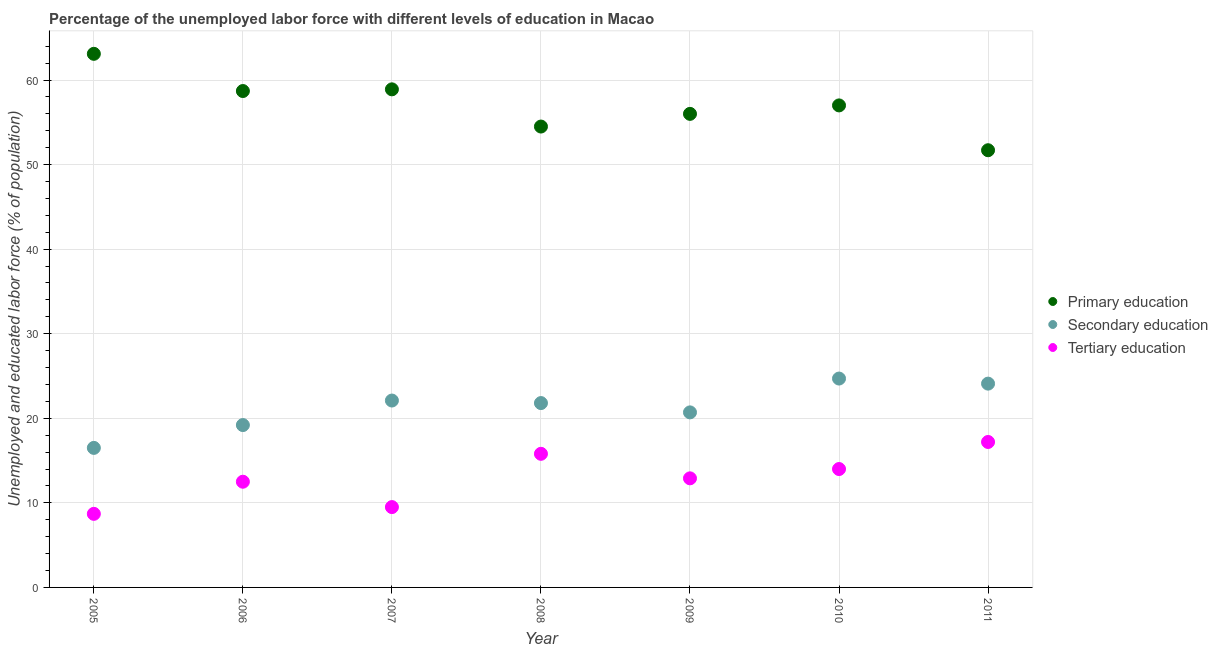Is the number of dotlines equal to the number of legend labels?
Your answer should be compact. Yes. What is the percentage of labor force who received secondary education in 2009?
Your answer should be compact. 20.7. Across all years, what is the maximum percentage of labor force who received secondary education?
Your response must be concise. 24.7. Across all years, what is the minimum percentage of labor force who received primary education?
Provide a short and direct response. 51.7. In which year was the percentage of labor force who received primary education maximum?
Provide a succinct answer. 2005. In which year was the percentage of labor force who received tertiary education minimum?
Make the answer very short. 2005. What is the total percentage of labor force who received secondary education in the graph?
Your answer should be compact. 149.1. What is the difference between the percentage of labor force who received secondary education in 2006 and the percentage of labor force who received tertiary education in 2008?
Your answer should be compact. 3.4. What is the average percentage of labor force who received secondary education per year?
Provide a short and direct response. 21.3. In the year 2007, what is the difference between the percentage of labor force who received secondary education and percentage of labor force who received tertiary education?
Your answer should be very brief. 12.6. What is the ratio of the percentage of labor force who received primary education in 2008 to that in 2009?
Offer a terse response. 0.97. Is the percentage of labor force who received primary education in 2007 less than that in 2010?
Keep it short and to the point. No. What is the difference between the highest and the second highest percentage of labor force who received primary education?
Give a very brief answer. 4.2. What is the difference between the highest and the lowest percentage of labor force who received secondary education?
Keep it short and to the point. 8.2. In how many years, is the percentage of labor force who received secondary education greater than the average percentage of labor force who received secondary education taken over all years?
Your answer should be compact. 4. Is the sum of the percentage of labor force who received tertiary education in 2005 and 2011 greater than the maximum percentage of labor force who received primary education across all years?
Offer a terse response. No. How many years are there in the graph?
Give a very brief answer. 7. How many legend labels are there?
Provide a succinct answer. 3. How are the legend labels stacked?
Offer a terse response. Vertical. What is the title of the graph?
Provide a short and direct response. Percentage of the unemployed labor force with different levels of education in Macao. Does "Taxes on goods and services" appear as one of the legend labels in the graph?
Offer a terse response. No. What is the label or title of the Y-axis?
Offer a very short reply. Unemployed and educated labor force (% of population). What is the Unemployed and educated labor force (% of population) in Primary education in 2005?
Offer a very short reply. 63.1. What is the Unemployed and educated labor force (% of population) in Secondary education in 2005?
Your response must be concise. 16.5. What is the Unemployed and educated labor force (% of population) in Tertiary education in 2005?
Provide a short and direct response. 8.7. What is the Unemployed and educated labor force (% of population) in Primary education in 2006?
Your answer should be compact. 58.7. What is the Unemployed and educated labor force (% of population) in Secondary education in 2006?
Offer a terse response. 19.2. What is the Unemployed and educated labor force (% of population) of Primary education in 2007?
Offer a very short reply. 58.9. What is the Unemployed and educated labor force (% of population) in Secondary education in 2007?
Provide a succinct answer. 22.1. What is the Unemployed and educated labor force (% of population) of Primary education in 2008?
Your answer should be very brief. 54.5. What is the Unemployed and educated labor force (% of population) of Secondary education in 2008?
Keep it short and to the point. 21.8. What is the Unemployed and educated labor force (% of population) in Tertiary education in 2008?
Keep it short and to the point. 15.8. What is the Unemployed and educated labor force (% of population) of Secondary education in 2009?
Offer a terse response. 20.7. What is the Unemployed and educated labor force (% of population) of Tertiary education in 2009?
Your response must be concise. 12.9. What is the Unemployed and educated labor force (% of population) in Secondary education in 2010?
Ensure brevity in your answer.  24.7. What is the Unemployed and educated labor force (% of population) in Tertiary education in 2010?
Ensure brevity in your answer.  14. What is the Unemployed and educated labor force (% of population) of Primary education in 2011?
Your answer should be compact. 51.7. What is the Unemployed and educated labor force (% of population) of Secondary education in 2011?
Keep it short and to the point. 24.1. What is the Unemployed and educated labor force (% of population) of Tertiary education in 2011?
Make the answer very short. 17.2. Across all years, what is the maximum Unemployed and educated labor force (% of population) of Primary education?
Offer a terse response. 63.1. Across all years, what is the maximum Unemployed and educated labor force (% of population) of Secondary education?
Provide a short and direct response. 24.7. Across all years, what is the maximum Unemployed and educated labor force (% of population) in Tertiary education?
Make the answer very short. 17.2. Across all years, what is the minimum Unemployed and educated labor force (% of population) in Primary education?
Your answer should be compact. 51.7. Across all years, what is the minimum Unemployed and educated labor force (% of population) in Tertiary education?
Provide a short and direct response. 8.7. What is the total Unemployed and educated labor force (% of population) of Primary education in the graph?
Offer a terse response. 399.9. What is the total Unemployed and educated labor force (% of population) of Secondary education in the graph?
Your answer should be compact. 149.1. What is the total Unemployed and educated labor force (% of population) of Tertiary education in the graph?
Your response must be concise. 90.6. What is the difference between the Unemployed and educated labor force (% of population) of Secondary education in 2005 and that in 2006?
Make the answer very short. -2.7. What is the difference between the Unemployed and educated labor force (% of population) of Secondary education in 2005 and that in 2007?
Make the answer very short. -5.6. What is the difference between the Unemployed and educated labor force (% of population) in Tertiary education in 2005 and that in 2007?
Make the answer very short. -0.8. What is the difference between the Unemployed and educated labor force (% of population) of Secondary education in 2005 and that in 2008?
Offer a terse response. -5.3. What is the difference between the Unemployed and educated labor force (% of population) in Primary education in 2005 and that in 2009?
Ensure brevity in your answer.  7.1. What is the difference between the Unemployed and educated labor force (% of population) in Secondary education in 2005 and that in 2009?
Keep it short and to the point. -4.2. What is the difference between the Unemployed and educated labor force (% of population) in Tertiary education in 2005 and that in 2010?
Offer a very short reply. -5.3. What is the difference between the Unemployed and educated labor force (% of population) in Primary education in 2005 and that in 2011?
Ensure brevity in your answer.  11.4. What is the difference between the Unemployed and educated labor force (% of population) of Tertiary education in 2005 and that in 2011?
Give a very brief answer. -8.5. What is the difference between the Unemployed and educated labor force (% of population) of Primary education in 2006 and that in 2007?
Your answer should be very brief. -0.2. What is the difference between the Unemployed and educated labor force (% of population) of Secondary education in 2006 and that in 2007?
Offer a very short reply. -2.9. What is the difference between the Unemployed and educated labor force (% of population) in Primary education in 2006 and that in 2008?
Provide a short and direct response. 4.2. What is the difference between the Unemployed and educated labor force (% of population) of Secondary education in 2006 and that in 2008?
Make the answer very short. -2.6. What is the difference between the Unemployed and educated labor force (% of population) of Tertiary education in 2006 and that in 2008?
Provide a succinct answer. -3.3. What is the difference between the Unemployed and educated labor force (% of population) in Secondary education in 2006 and that in 2009?
Offer a terse response. -1.5. What is the difference between the Unemployed and educated labor force (% of population) of Tertiary education in 2006 and that in 2009?
Give a very brief answer. -0.4. What is the difference between the Unemployed and educated labor force (% of population) in Primary education in 2006 and that in 2011?
Your response must be concise. 7. What is the difference between the Unemployed and educated labor force (% of population) of Secondary education in 2006 and that in 2011?
Give a very brief answer. -4.9. What is the difference between the Unemployed and educated labor force (% of population) in Tertiary education in 2006 and that in 2011?
Keep it short and to the point. -4.7. What is the difference between the Unemployed and educated labor force (% of population) of Secondary education in 2007 and that in 2008?
Your response must be concise. 0.3. What is the difference between the Unemployed and educated labor force (% of population) in Tertiary education in 2007 and that in 2009?
Keep it short and to the point. -3.4. What is the difference between the Unemployed and educated labor force (% of population) in Tertiary education in 2007 and that in 2010?
Ensure brevity in your answer.  -4.5. What is the difference between the Unemployed and educated labor force (% of population) of Primary education in 2007 and that in 2011?
Keep it short and to the point. 7.2. What is the difference between the Unemployed and educated labor force (% of population) of Tertiary education in 2007 and that in 2011?
Make the answer very short. -7.7. What is the difference between the Unemployed and educated labor force (% of population) of Primary education in 2008 and that in 2009?
Provide a succinct answer. -1.5. What is the difference between the Unemployed and educated labor force (% of population) in Tertiary education in 2008 and that in 2009?
Give a very brief answer. 2.9. What is the difference between the Unemployed and educated labor force (% of population) in Primary education in 2008 and that in 2010?
Your answer should be very brief. -2.5. What is the difference between the Unemployed and educated labor force (% of population) of Secondary education in 2008 and that in 2010?
Provide a short and direct response. -2.9. What is the difference between the Unemployed and educated labor force (% of population) of Tertiary education in 2008 and that in 2010?
Make the answer very short. 1.8. What is the difference between the Unemployed and educated labor force (% of population) of Secondary education in 2009 and that in 2010?
Your response must be concise. -4. What is the difference between the Unemployed and educated labor force (% of population) of Tertiary education in 2009 and that in 2010?
Offer a very short reply. -1.1. What is the difference between the Unemployed and educated labor force (% of population) of Secondary education in 2009 and that in 2011?
Ensure brevity in your answer.  -3.4. What is the difference between the Unemployed and educated labor force (% of population) of Primary education in 2010 and that in 2011?
Offer a very short reply. 5.3. What is the difference between the Unemployed and educated labor force (% of population) in Tertiary education in 2010 and that in 2011?
Offer a terse response. -3.2. What is the difference between the Unemployed and educated labor force (% of population) of Primary education in 2005 and the Unemployed and educated labor force (% of population) of Secondary education in 2006?
Your response must be concise. 43.9. What is the difference between the Unemployed and educated labor force (% of population) in Primary education in 2005 and the Unemployed and educated labor force (% of population) in Tertiary education in 2006?
Offer a terse response. 50.6. What is the difference between the Unemployed and educated labor force (% of population) in Primary education in 2005 and the Unemployed and educated labor force (% of population) in Tertiary education in 2007?
Offer a terse response. 53.6. What is the difference between the Unemployed and educated labor force (% of population) in Primary education in 2005 and the Unemployed and educated labor force (% of population) in Secondary education in 2008?
Ensure brevity in your answer.  41.3. What is the difference between the Unemployed and educated labor force (% of population) in Primary education in 2005 and the Unemployed and educated labor force (% of population) in Tertiary education in 2008?
Your response must be concise. 47.3. What is the difference between the Unemployed and educated labor force (% of population) of Primary education in 2005 and the Unemployed and educated labor force (% of population) of Secondary education in 2009?
Offer a terse response. 42.4. What is the difference between the Unemployed and educated labor force (% of population) in Primary education in 2005 and the Unemployed and educated labor force (% of population) in Tertiary education in 2009?
Your answer should be very brief. 50.2. What is the difference between the Unemployed and educated labor force (% of population) in Primary education in 2005 and the Unemployed and educated labor force (% of population) in Secondary education in 2010?
Your answer should be very brief. 38.4. What is the difference between the Unemployed and educated labor force (% of population) in Primary education in 2005 and the Unemployed and educated labor force (% of population) in Tertiary education in 2010?
Keep it short and to the point. 49.1. What is the difference between the Unemployed and educated labor force (% of population) in Primary education in 2005 and the Unemployed and educated labor force (% of population) in Tertiary education in 2011?
Make the answer very short. 45.9. What is the difference between the Unemployed and educated labor force (% of population) of Secondary education in 2005 and the Unemployed and educated labor force (% of population) of Tertiary education in 2011?
Make the answer very short. -0.7. What is the difference between the Unemployed and educated labor force (% of population) of Primary education in 2006 and the Unemployed and educated labor force (% of population) of Secondary education in 2007?
Ensure brevity in your answer.  36.6. What is the difference between the Unemployed and educated labor force (% of population) of Primary education in 2006 and the Unemployed and educated labor force (% of population) of Tertiary education in 2007?
Ensure brevity in your answer.  49.2. What is the difference between the Unemployed and educated labor force (% of population) of Secondary education in 2006 and the Unemployed and educated labor force (% of population) of Tertiary education in 2007?
Your response must be concise. 9.7. What is the difference between the Unemployed and educated labor force (% of population) of Primary education in 2006 and the Unemployed and educated labor force (% of population) of Secondary education in 2008?
Your answer should be compact. 36.9. What is the difference between the Unemployed and educated labor force (% of population) in Primary education in 2006 and the Unemployed and educated labor force (% of population) in Tertiary education in 2008?
Your answer should be compact. 42.9. What is the difference between the Unemployed and educated labor force (% of population) of Primary education in 2006 and the Unemployed and educated labor force (% of population) of Secondary education in 2009?
Offer a terse response. 38. What is the difference between the Unemployed and educated labor force (% of population) in Primary education in 2006 and the Unemployed and educated labor force (% of population) in Tertiary education in 2009?
Your response must be concise. 45.8. What is the difference between the Unemployed and educated labor force (% of population) of Secondary education in 2006 and the Unemployed and educated labor force (% of population) of Tertiary education in 2009?
Provide a short and direct response. 6.3. What is the difference between the Unemployed and educated labor force (% of population) of Primary education in 2006 and the Unemployed and educated labor force (% of population) of Secondary education in 2010?
Give a very brief answer. 34. What is the difference between the Unemployed and educated labor force (% of population) of Primary education in 2006 and the Unemployed and educated labor force (% of population) of Tertiary education in 2010?
Provide a succinct answer. 44.7. What is the difference between the Unemployed and educated labor force (% of population) in Secondary education in 2006 and the Unemployed and educated labor force (% of population) in Tertiary education in 2010?
Your answer should be compact. 5.2. What is the difference between the Unemployed and educated labor force (% of population) of Primary education in 2006 and the Unemployed and educated labor force (% of population) of Secondary education in 2011?
Your answer should be compact. 34.6. What is the difference between the Unemployed and educated labor force (% of population) of Primary education in 2006 and the Unemployed and educated labor force (% of population) of Tertiary education in 2011?
Provide a succinct answer. 41.5. What is the difference between the Unemployed and educated labor force (% of population) of Primary education in 2007 and the Unemployed and educated labor force (% of population) of Secondary education in 2008?
Keep it short and to the point. 37.1. What is the difference between the Unemployed and educated labor force (% of population) in Primary education in 2007 and the Unemployed and educated labor force (% of population) in Tertiary education in 2008?
Offer a very short reply. 43.1. What is the difference between the Unemployed and educated labor force (% of population) of Secondary education in 2007 and the Unemployed and educated labor force (% of population) of Tertiary education in 2008?
Offer a very short reply. 6.3. What is the difference between the Unemployed and educated labor force (% of population) of Primary education in 2007 and the Unemployed and educated labor force (% of population) of Secondary education in 2009?
Keep it short and to the point. 38.2. What is the difference between the Unemployed and educated labor force (% of population) in Primary education in 2007 and the Unemployed and educated labor force (% of population) in Secondary education in 2010?
Your answer should be compact. 34.2. What is the difference between the Unemployed and educated labor force (% of population) in Primary education in 2007 and the Unemployed and educated labor force (% of population) in Tertiary education in 2010?
Your response must be concise. 44.9. What is the difference between the Unemployed and educated labor force (% of population) of Primary education in 2007 and the Unemployed and educated labor force (% of population) of Secondary education in 2011?
Your answer should be very brief. 34.8. What is the difference between the Unemployed and educated labor force (% of population) in Primary education in 2007 and the Unemployed and educated labor force (% of population) in Tertiary education in 2011?
Your answer should be very brief. 41.7. What is the difference between the Unemployed and educated labor force (% of population) in Secondary education in 2007 and the Unemployed and educated labor force (% of population) in Tertiary education in 2011?
Give a very brief answer. 4.9. What is the difference between the Unemployed and educated labor force (% of population) of Primary education in 2008 and the Unemployed and educated labor force (% of population) of Secondary education in 2009?
Your answer should be compact. 33.8. What is the difference between the Unemployed and educated labor force (% of population) in Primary education in 2008 and the Unemployed and educated labor force (% of population) in Tertiary education in 2009?
Your answer should be compact. 41.6. What is the difference between the Unemployed and educated labor force (% of population) in Primary education in 2008 and the Unemployed and educated labor force (% of population) in Secondary education in 2010?
Provide a succinct answer. 29.8. What is the difference between the Unemployed and educated labor force (% of population) in Primary education in 2008 and the Unemployed and educated labor force (% of population) in Tertiary education in 2010?
Your answer should be compact. 40.5. What is the difference between the Unemployed and educated labor force (% of population) of Secondary education in 2008 and the Unemployed and educated labor force (% of population) of Tertiary education in 2010?
Provide a short and direct response. 7.8. What is the difference between the Unemployed and educated labor force (% of population) of Primary education in 2008 and the Unemployed and educated labor force (% of population) of Secondary education in 2011?
Your response must be concise. 30.4. What is the difference between the Unemployed and educated labor force (% of population) in Primary education in 2008 and the Unemployed and educated labor force (% of population) in Tertiary education in 2011?
Ensure brevity in your answer.  37.3. What is the difference between the Unemployed and educated labor force (% of population) in Primary education in 2009 and the Unemployed and educated labor force (% of population) in Secondary education in 2010?
Give a very brief answer. 31.3. What is the difference between the Unemployed and educated labor force (% of population) of Primary education in 2009 and the Unemployed and educated labor force (% of population) of Secondary education in 2011?
Ensure brevity in your answer.  31.9. What is the difference between the Unemployed and educated labor force (% of population) of Primary education in 2009 and the Unemployed and educated labor force (% of population) of Tertiary education in 2011?
Provide a succinct answer. 38.8. What is the difference between the Unemployed and educated labor force (% of population) in Secondary education in 2009 and the Unemployed and educated labor force (% of population) in Tertiary education in 2011?
Your response must be concise. 3.5. What is the difference between the Unemployed and educated labor force (% of population) of Primary education in 2010 and the Unemployed and educated labor force (% of population) of Secondary education in 2011?
Offer a terse response. 32.9. What is the difference between the Unemployed and educated labor force (% of population) in Primary education in 2010 and the Unemployed and educated labor force (% of population) in Tertiary education in 2011?
Keep it short and to the point. 39.8. What is the average Unemployed and educated labor force (% of population) in Primary education per year?
Offer a very short reply. 57.13. What is the average Unemployed and educated labor force (% of population) of Secondary education per year?
Keep it short and to the point. 21.3. What is the average Unemployed and educated labor force (% of population) in Tertiary education per year?
Your answer should be compact. 12.94. In the year 2005, what is the difference between the Unemployed and educated labor force (% of population) in Primary education and Unemployed and educated labor force (% of population) in Secondary education?
Offer a terse response. 46.6. In the year 2005, what is the difference between the Unemployed and educated labor force (% of population) in Primary education and Unemployed and educated labor force (% of population) in Tertiary education?
Your response must be concise. 54.4. In the year 2005, what is the difference between the Unemployed and educated labor force (% of population) in Secondary education and Unemployed and educated labor force (% of population) in Tertiary education?
Ensure brevity in your answer.  7.8. In the year 2006, what is the difference between the Unemployed and educated labor force (% of population) of Primary education and Unemployed and educated labor force (% of population) of Secondary education?
Give a very brief answer. 39.5. In the year 2006, what is the difference between the Unemployed and educated labor force (% of population) of Primary education and Unemployed and educated labor force (% of population) of Tertiary education?
Make the answer very short. 46.2. In the year 2006, what is the difference between the Unemployed and educated labor force (% of population) in Secondary education and Unemployed and educated labor force (% of population) in Tertiary education?
Ensure brevity in your answer.  6.7. In the year 2007, what is the difference between the Unemployed and educated labor force (% of population) in Primary education and Unemployed and educated labor force (% of population) in Secondary education?
Provide a succinct answer. 36.8. In the year 2007, what is the difference between the Unemployed and educated labor force (% of population) in Primary education and Unemployed and educated labor force (% of population) in Tertiary education?
Your response must be concise. 49.4. In the year 2008, what is the difference between the Unemployed and educated labor force (% of population) in Primary education and Unemployed and educated labor force (% of population) in Secondary education?
Your answer should be very brief. 32.7. In the year 2008, what is the difference between the Unemployed and educated labor force (% of population) of Primary education and Unemployed and educated labor force (% of population) of Tertiary education?
Offer a terse response. 38.7. In the year 2009, what is the difference between the Unemployed and educated labor force (% of population) in Primary education and Unemployed and educated labor force (% of population) in Secondary education?
Keep it short and to the point. 35.3. In the year 2009, what is the difference between the Unemployed and educated labor force (% of population) of Primary education and Unemployed and educated labor force (% of population) of Tertiary education?
Provide a short and direct response. 43.1. In the year 2010, what is the difference between the Unemployed and educated labor force (% of population) of Primary education and Unemployed and educated labor force (% of population) of Secondary education?
Provide a short and direct response. 32.3. In the year 2010, what is the difference between the Unemployed and educated labor force (% of population) of Secondary education and Unemployed and educated labor force (% of population) of Tertiary education?
Provide a short and direct response. 10.7. In the year 2011, what is the difference between the Unemployed and educated labor force (% of population) in Primary education and Unemployed and educated labor force (% of population) in Secondary education?
Offer a terse response. 27.6. In the year 2011, what is the difference between the Unemployed and educated labor force (% of population) of Primary education and Unemployed and educated labor force (% of population) of Tertiary education?
Your response must be concise. 34.5. What is the ratio of the Unemployed and educated labor force (% of population) of Primary education in 2005 to that in 2006?
Your answer should be very brief. 1.07. What is the ratio of the Unemployed and educated labor force (% of population) in Secondary education in 2005 to that in 2006?
Offer a terse response. 0.86. What is the ratio of the Unemployed and educated labor force (% of population) of Tertiary education in 2005 to that in 2006?
Provide a succinct answer. 0.7. What is the ratio of the Unemployed and educated labor force (% of population) of Primary education in 2005 to that in 2007?
Provide a short and direct response. 1.07. What is the ratio of the Unemployed and educated labor force (% of population) in Secondary education in 2005 to that in 2007?
Ensure brevity in your answer.  0.75. What is the ratio of the Unemployed and educated labor force (% of population) in Tertiary education in 2005 to that in 2007?
Give a very brief answer. 0.92. What is the ratio of the Unemployed and educated labor force (% of population) in Primary education in 2005 to that in 2008?
Keep it short and to the point. 1.16. What is the ratio of the Unemployed and educated labor force (% of population) of Secondary education in 2005 to that in 2008?
Give a very brief answer. 0.76. What is the ratio of the Unemployed and educated labor force (% of population) in Tertiary education in 2005 to that in 2008?
Offer a terse response. 0.55. What is the ratio of the Unemployed and educated labor force (% of population) of Primary education in 2005 to that in 2009?
Make the answer very short. 1.13. What is the ratio of the Unemployed and educated labor force (% of population) in Secondary education in 2005 to that in 2009?
Keep it short and to the point. 0.8. What is the ratio of the Unemployed and educated labor force (% of population) in Tertiary education in 2005 to that in 2009?
Provide a succinct answer. 0.67. What is the ratio of the Unemployed and educated labor force (% of population) of Primary education in 2005 to that in 2010?
Keep it short and to the point. 1.11. What is the ratio of the Unemployed and educated labor force (% of population) of Secondary education in 2005 to that in 2010?
Offer a terse response. 0.67. What is the ratio of the Unemployed and educated labor force (% of population) of Tertiary education in 2005 to that in 2010?
Your response must be concise. 0.62. What is the ratio of the Unemployed and educated labor force (% of population) of Primary education in 2005 to that in 2011?
Offer a very short reply. 1.22. What is the ratio of the Unemployed and educated labor force (% of population) of Secondary education in 2005 to that in 2011?
Ensure brevity in your answer.  0.68. What is the ratio of the Unemployed and educated labor force (% of population) of Tertiary education in 2005 to that in 2011?
Offer a terse response. 0.51. What is the ratio of the Unemployed and educated labor force (% of population) of Secondary education in 2006 to that in 2007?
Ensure brevity in your answer.  0.87. What is the ratio of the Unemployed and educated labor force (% of population) in Tertiary education in 2006 to that in 2007?
Ensure brevity in your answer.  1.32. What is the ratio of the Unemployed and educated labor force (% of population) in Primary education in 2006 to that in 2008?
Offer a terse response. 1.08. What is the ratio of the Unemployed and educated labor force (% of population) in Secondary education in 2006 to that in 2008?
Provide a succinct answer. 0.88. What is the ratio of the Unemployed and educated labor force (% of population) in Tertiary education in 2006 to that in 2008?
Your answer should be compact. 0.79. What is the ratio of the Unemployed and educated labor force (% of population) of Primary education in 2006 to that in 2009?
Keep it short and to the point. 1.05. What is the ratio of the Unemployed and educated labor force (% of population) in Secondary education in 2006 to that in 2009?
Make the answer very short. 0.93. What is the ratio of the Unemployed and educated labor force (% of population) of Primary education in 2006 to that in 2010?
Your answer should be very brief. 1.03. What is the ratio of the Unemployed and educated labor force (% of population) of Secondary education in 2006 to that in 2010?
Offer a very short reply. 0.78. What is the ratio of the Unemployed and educated labor force (% of population) in Tertiary education in 2006 to that in 2010?
Ensure brevity in your answer.  0.89. What is the ratio of the Unemployed and educated labor force (% of population) of Primary education in 2006 to that in 2011?
Offer a terse response. 1.14. What is the ratio of the Unemployed and educated labor force (% of population) of Secondary education in 2006 to that in 2011?
Provide a short and direct response. 0.8. What is the ratio of the Unemployed and educated labor force (% of population) in Tertiary education in 2006 to that in 2011?
Ensure brevity in your answer.  0.73. What is the ratio of the Unemployed and educated labor force (% of population) in Primary education in 2007 to that in 2008?
Your answer should be very brief. 1.08. What is the ratio of the Unemployed and educated labor force (% of population) in Secondary education in 2007 to that in 2008?
Provide a succinct answer. 1.01. What is the ratio of the Unemployed and educated labor force (% of population) in Tertiary education in 2007 to that in 2008?
Give a very brief answer. 0.6. What is the ratio of the Unemployed and educated labor force (% of population) in Primary education in 2007 to that in 2009?
Offer a terse response. 1.05. What is the ratio of the Unemployed and educated labor force (% of population) in Secondary education in 2007 to that in 2009?
Offer a terse response. 1.07. What is the ratio of the Unemployed and educated labor force (% of population) of Tertiary education in 2007 to that in 2009?
Provide a short and direct response. 0.74. What is the ratio of the Unemployed and educated labor force (% of population) of Primary education in 2007 to that in 2010?
Your answer should be compact. 1.03. What is the ratio of the Unemployed and educated labor force (% of population) of Secondary education in 2007 to that in 2010?
Provide a succinct answer. 0.89. What is the ratio of the Unemployed and educated labor force (% of population) of Tertiary education in 2007 to that in 2010?
Offer a very short reply. 0.68. What is the ratio of the Unemployed and educated labor force (% of population) in Primary education in 2007 to that in 2011?
Give a very brief answer. 1.14. What is the ratio of the Unemployed and educated labor force (% of population) of Secondary education in 2007 to that in 2011?
Provide a short and direct response. 0.92. What is the ratio of the Unemployed and educated labor force (% of population) in Tertiary education in 2007 to that in 2011?
Make the answer very short. 0.55. What is the ratio of the Unemployed and educated labor force (% of population) in Primary education in 2008 to that in 2009?
Your answer should be compact. 0.97. What is the ratio of the Unemployed and educated labor force (% of population) of Secondary education in 2008 to that in 2009?
Give a very brief answer. 1.05. What is the ratio of the Unemployed and educated labor force (% of population) of Tertiary education in 2008 to that in 2009?
Provide a short and direct response. 1.22. What is the ratio of the Unemployed and educated labor force (% of population) of Primary education in 2008 to that in 2010?
Your answer should be very brief. 0.96. What is the ratio of the Unemployed and educated labor force (% of population) in Secondary education in 2008 to that in 2010?
Offer a very short reply. 0.88. What is the ratio of the Unemployed and educated labor force (% of population) in Tertiary education in 2008 to that in 2010?
Your response must be concise. 1.13. What is the ratio of the Unemployed and educated labor force (% of population) of Primary education in 2008 to that in 2011?
Ensure brevity in your answer.  1.05. What is the ratio of the Unemployed and educated labor force (% of population) in Secondary education in 2008 to that in 2011?
Your answer should be compact. 0.9. What is the ratio of the Unemployed and educated labor force (% of population) of Tertiary education in 2008 to that in 2011?
Ensure brevity in your answer.  0.92. What is the ratio of the Unemployed and educated labor force (% of population) of Primary education in 2009 to that in 2010?
Offer a terse response. 0.98. What is the ratio of the Unemployed and educated labor force (% of population) in Secondary education in 2009 to that in 2010?
Your answer should be very brief. 0.84. What is the ratio of the Unemployed and educated labor force (% of population) in Tertiary education in 2009 to that in 2010?
Your answer should be very brief. 0.92. What is the ratio of the Unemployed and educated labor force (% of population) of Primary education in 2009 to that in 2011?
Provide a succinct answer. 1.08. What is the ratio of the Unemployed and educated labor force (% of population) of Secondary education in 2009 to that in 2011?
Your answer should be compact. 0.86. What is the ratio of the Unemployed and educated labor force (% of population) of Tertiary education in 2009 to that in 2011?
Your answer should be very brief. 0.75. What is the ratio of the Unemployed and educated labor force (% of population) of Primary education in 2010 to that in 2011?
Provide a short and direct response. 1.1. What is the ratio of the Unemployed and educated labor force (% of population) of Secondary education in 2010 to that in 2011?
Provide a short and direct response. 1.02. What is the ratio of the Unemployed and educated labor force (% of population) of Tertiary education in 2010 to that in 2011?
Make the answer very short. 0.81. What is the difference between the highest and the second highest Unemployed and educated labor force (% of population) of Primary education?
Ensure brevity in your answer.  4.2. What is the difference between the highest and the lowest Unemployed and educated labor force (% of population) in Primary education?
Keep it short and to the point. 11.4. What is the difference between the highest and the lowest Unemployed and educated labor force (% of population) of Secondary education?
Make the answer very short. 8.2. 